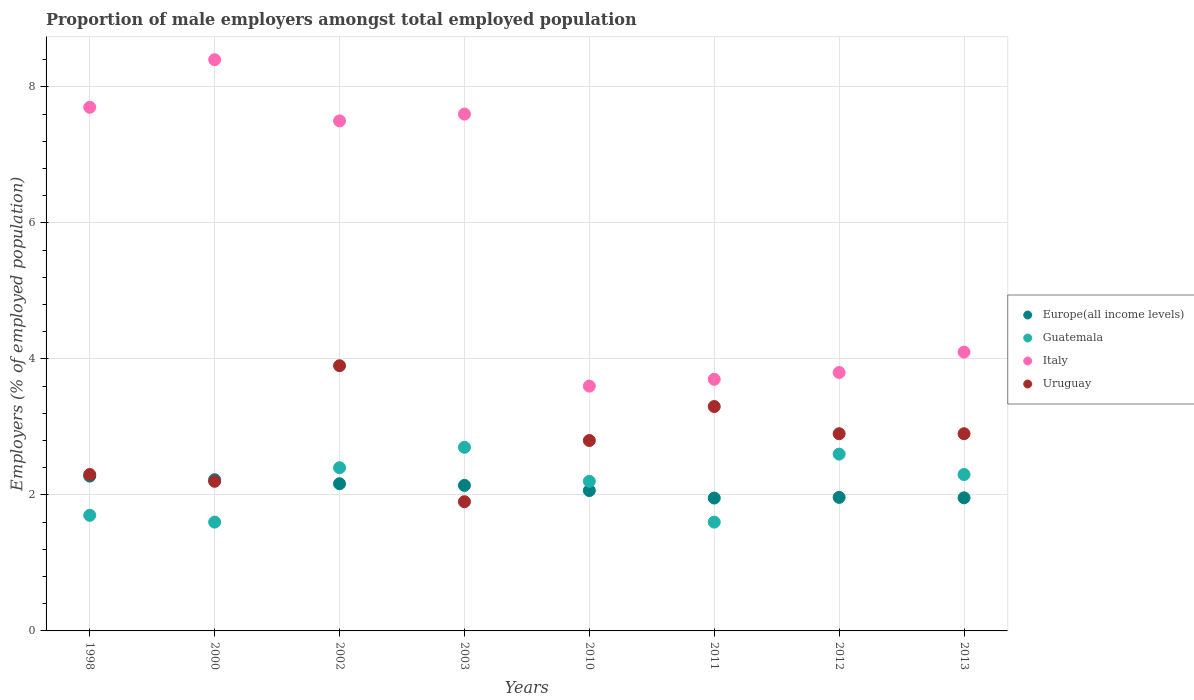How many different coloured dotlines are there?
Offer a terse response. 4. What is the proportion of male employers in Italy in 2010?
Ensure brevity in your answer.  3.6. Across all years, what is the maximum proportion of male employers in Uruguay?
Your answer should be very brief. 3.9. Across all years, what is the minimum proportion of male employers in Uruguay?
Your response must be concise. 1.9. What is the total proportion of male employers in Uruguay in the graph?
Give a very brief answer. 22.2. What is the difference between the proportion of male employers in Europe(all income levels) in 2002 and that in 2011?
Make the answer very short. 0.21. What is the difference between the proportion of male employers in Italy in 1998 and the proportion of male employers in Europe(all income levels) in 2012?
Offer a very short reply. 5.74. What is the average proportion of male employers in Italy per year?
Provide a short and direct response. 5.8. In the year 2012, what is the difference between the proportion of male employers in Italy and proportion of male employers in Uruguay?
Keep it short and to the point. 0.9. What is the ratio of the proportion of male employers in Uruguay in 2011 to that in 2013?
Offer a terse response. 1.14. Is the proportion of male employers in Uruguay in 2000 less than that in 2012?
Provide a succinct answer. Yes. What is the difference between the highest and the second highest proportion of male employers in Europe(all income levels)?
Make the answer very short. 0.05. What is the difference between the highest and the lowest proportion of male employers in Italy?
Your response must be concise. 4.8. In how many years, is the proportion of male employers in Europe(all income levels) greater than the average proportion of male employers in Europe(all income levels) taken over all years?
Your answer should be compact. 4. Is it the case that in every year, the sum of the proportion of male employers in Guatemala and proportion of male employers in Uruguay  is greater than the proportion of male employers in Italy?
Provide a short and direct response. No. How many dotlines are there?
Offer a very short reply. 4. What is the difference between two consecutive major ticks on the Y-axis?
Your answer should be compact. 2. How are the legend labels stacked?
Your response must be concise. Vertical. What is the title of the graph?
Offer a very short reply. Proportion of male employers amongst total employed population. What is the label or title of the X-axis?
Keep it short and to the point. Years. What is the label or title of the Y-axis?
Keep it short and to the point. Employers (% of employed population). What is the Employers (% of employed population) in Europe(all income levels) in 1998?
Provide a short and direct response. 2.28. What is the Employers (% of employed population) of Guatemala in 1998?
Provide a succinct answer. 1.7. What is the Employers (% of employed population) in Italy in 1998?
Give a very brief answer. 7.7. What is the Employers (% of employed population) in Uruguay in 1998?
Give a very brief answer. 2.3. What is the Employers (% of employed population) of Europe(all income levels) in 2000?
Offer a terse response. 2.22. What is the Employers (% of employed population) of Guatemala in 2000?
Your response must be concise. 1.6. What is the Employers (% of employed population) in Italy in 2000?
Your answer should be very brief. 8.4. What is the Employers (% of employed population) in Uruguay in 2000?
Provide a succinct answer. 2.2. What is the Employers (% of employed population) of Europe(all income levels) in 2002?
Your response must be concise. 2.16. What is the Employers (% of employed population) of Guatemala in 2002?
Provide a succinct answer. 2.4. What is the Employers (% of employed population) in Italy in 2002?
Your response must be concise. 7.5. What is the Employers (% of employed population) in Uruguay in 2002?
Ensure brevity in your answer.  3.9. What is the Employers (% of employed population) of Europe(all income levels) in 2003?
Keep it short and to the point. 2.14. What is the Employers (% of employed population) of Guatemala in 2003?
Give a very brief answer. 2.7. What is the Employers (% of employed population) in Italy in 2003?
Ensure brevity in your answer.  7.6. What is the Employers (% of employed population) in Uruguay in 2003?
Keep it short and to the point. 1.9. What is the Employers (% of employed population) of Europe(all income levels) in 2010?
Ensure brevity in your answer.  2.06. What is the Employers (% of employed population) in Guatemala in 2010?
Your answer should be compact. 2.2. What is the Employers (% of employed population) of Italy in 2010?
Your response must be concise. 3.6. What is the Employers (% of employed population) of Uruguay in 2010?
Your answer should be compact. 2.8. What is the Employers (% of employed population) of Europe(all income levels) in 2011?
Provide a succinct answer. 1.95. What is the Employers (% of employed population) in Guatemala in 2011?
Offer a very short reply. 1.6. What is the Employers (% of employed population) in Italy in 2011?
Provide a succinct answer. 3.7. What is the Employers (% of employed population) of Uruguay in 2011?
Keep it short and to the point. 3.3. What is the Employers (% of employed population) in Europe(all income levels) in 2012?
Your answer should be compact. 1.96. What is the Employers (% of employed population) of Guatemala in 2012?
Give a very brief answer. 2.6. What is the Employers (% of employed population) in Italy in 2012?
Offer a very short reply. 3.8. What is the Employers (% of employed population) of Uruguay in 2012?
Your answer should be very brief. 2.9. What is the Employers (% of employed population) in Europe(all income levels) in 2013?
Offer a very short reply. 1.96. What is the Employers (% of employed population) of Guatemala in 2013?
Your answer should be very brief. 2.3. What is the Employers (% of employed population) of Italy in 2013?
Keep it short and to the point. 4.1. What is the Employers (% of employed population) in Uruguay in 2013?
Provide a succinct answer. 2.9. Across all years, what is the maximum Employers (% of employed population) in Europe(all income levels)?
Make the answer very short. 2.28. Across all years, what is the maximum Employers (% of employed population) in Guatemala?
Your response must be concise. 2.7. Across all years, what is the maximum Employers (% of employed population) of Italy?
Your response must be concise. 8.4. Across all years, what is the maximum Employers (% of employed population) in Uruguay?
Your response must be concise. 3.9. Across all years, what is the minimum Employers (% of employed population) of Europe(all income levels)?
Offer a terse response. 1.95. Across all years, what is the minimum Employers (% of employed population) in Guatemala?
Your answer should be very brief. 1.6. Across all years, what is the minimum Employers (% of employed population) in Italy?
Provide a succinct answer. 3.6. Across all years, what is the minimum Employers (% of employed population) in Uruguay?
Provide a short and direct response. 1.9. What is the total Employers (% of employed population) in Europe(all income levels) in the graph?
Your answer should be compact. 16.74. What is the total Employers (% of employed population) in Italy in the graph?
Provide a short and direct response. 46.4. What is the difference between the Employers (% of employed population) of Europe(all income levels) in 1998 and that in 2000?
Your answer should be compact. 0.05. What is the difference between the Employers (% of employed population) of Europe(all income levels) in 1998 and that in 2002?
Your answer should be compact. 0.11. What is the difference between the Employers (% of employed population) of Guatemala in 1998 and that in 2002?
Offer a terse response. -0.7. What is the difference between the Employers (% of employed population) of Italy in 1998 and that in 2002?
Keep it short and to the point. 0.2. What is the difference between the Employers (% of employed population) in Uruguay in 1998 and that in 2002?
Ensure brevity in your answer.  -1.6. What is the difference between the Employers (% of employed population) in Europe(all income levels) in 1998 and that in 2003?
Keep it short and to the point. 0.14. What is the difference between the Employers (% of employed population) of Uruguay in 1998 and that in 2003?
Provide a succinct answer. 0.4. What is the difference between the Employers (% of employed population) of Europe(all income levels) in 1998 and that in 2010?
Offer a very short reply. 0.21. What is the difference between the Employers (% of employed population) in Europe(all income levels) in 1998 and that in 2011?
Keep it short and to the point. 0.32. What is the difference between the Employers (% of employed population) of Italy in 1998 and that in 2011?
Keep it short and to the point. 4. What is the difference between the Employers (% of employed population) of Europe(all income levels) in 1998 and that in 2012?
Make the answer very short. 0.31. What is the difference between the Employers (% of employed population) in Guatemala in 1998 and that in 2012?
Keep it short and to the point. -0.9. What is the difference between the Employers (% of employed population) in Italy in 1998 and that in 2012?
Offer a terse response. 3.9. What is the difference between the Employers (% of employed population) in Europe(all income levels) in 1998 and that in 2013?
Provide a short and direct response. 0.32. What is the difference between the Employers (% of employed population) of Uruguay in 1998 and that in 2013?
Make the answer very short. -0.6. What is the difference between the Employers (% of employed population) of Europe(all income levels) in 2000 and that in 2002?
Provide a succinct answer. 0.06. What is the difference between the Employers (% of employed population) in Italy in 2000 and that in 2002?
Your answer should be very brief. 0.9. What is the difference between the Employers (% of employed population) of Uruguay in 2000 and that in 2002?
Your answer should be very brief. -1.7. What is the difference between the Employers (% of employed population) of Europe(all income levels) in 2000 and that in 2003?
Your response must be concise. 0.08. What is the difference between the Employers (% of employed population) of Uruguay in 2000 and that in 2003?
Offer a terse response. 0.3. What is the difference between the Employers (% of employed population) in Europe(all income levels) in 2000 and that in 2010?
Give a very brief answer. 0.16. What is the difference between the Employers (% of employed population) of Italy in 2000 and that in 2010?
Offer a terse response. 4.8. What is the difference between the Employers (% of employed population) in Europe(all income levels) in 2000 and that in 2011?
Provide a short and direct response. 0.27. What is the difference between the Employers (% of employed population) of Italy in 2000 and that in 2011?
Your response must be concise. 4.7. What is the difference between the Employers (% of employed population) in Europe(all income levels) in 2000 and that in 2012?
Make the answer very short. 0.26. What is the difference between the Employers (% of employed population) in Guatemala in 2000 and that in 2012?
Make the answer very short. -1. What is the difference between the Employers (% of employed population) in Italy in 2000 and that in 2012?
Offer a terse response. 4.6. What is the difference between the Employers (% of employed population) in Europe(all income levels) in 2000 and that in 2013?
Your answer should be compact. 0.27. What is the difference between the Employers (% of employed population) in Guatemala in 2000 and that in 2013?
Your response must be concise. -0.7. What is the difference between the Employers (% of employed population) of Europe(all income levels) in 2002 and that in 2003?
Provide a succinct answer. 0.02. What is the difference between the Employers (% of employed population) of Guatemala in 2002 and that in 2003?
Keep it short and to the point. -0.3. What is the difference between the Employers (% of employed population) of Europe(all income levels) in 2002 and that in 2010?
Give a very brief answer. 0.1. What is the difference between the Employers (% of employed population) of Guatemala in 2002 and that in 2010?
Your answer should be compact. 0.2. What is the difference between the Employers (% of employed population) in Italy in 2002 and that in 2010?
Your answer should be very brief. 3.9. What is the difference between the Employers (% of employed population) of Uruguay in 2002 and that in 2010?
Keep it short and to the point. 1.1. What is the difference between the Employers (% of employed population) in Europe(all income levels) in 2002 and that in 2011?
Your response must be concise. 0.21. What is the difference between the Employers (% of employed population) in Guatemala in 2002 and that in 2011?
Keep it short and to the point. 0.8. What is the difference between the Employers (% of employed population) in Italy in 2002 and that in 2011?
Offer a very short reply. 3.8. What is the difference between the Employers (% of employed population) of Europe(all income levels) in 2002 and that in 2012?
Give a very brief answer. 0.2. What is the difference between the Employers (% of employed population) of Italy in 2002 and that in 2012?
Provide a succinct answer. 3.7. What is the difference between the Employers (% of employed population) of Europe(all income levels) in 2002 and that in 2013?
Offer a terse response. 0.21. What is the difference between the Employers (% of employed population) in Guatemala in 2002 and that in 2013?
Provide a succinct answer. 0.1. What is the difference between the Employers (% of employed population) in Italy in 2002 and that in 2013?
Your response must be concise. 3.4. What is the difference between the Employers (% of employed population) in Europe(all income levels) in 2003 and that in 2010?
Offer a very short reply. 0.08. What is the difference between the Employers (% of employed population) in Guatemala in 2003 and that in 2010?
Ensure brevity in your answer.  0.5. What is the difference between the Employers (% of employed population) of Europe(all income levels) in 2003 and that in 2011?
Your answer should be very brief. 0.19. What is the difference between the Employers (% of employed population) in Guatemala in 2003 and that in 2011?
Offer a terse response. 1.1. What is the difference between the Employers (% of employed population) of Italy in 2003 and that in 2011?
Make the answer very short. 3.9. What is the difference between the Employers (% of employed population) in Europe(all income levels) in 2003 and that in 2012?
Provide a short and direct response. 0.18. What is the difference between the Employers (% of employed population) in Europe(all income levels) in 2003 and that in 2013?
Offer a terse response. 0.18. What is the difference between the Employers (% of employed population) in Guatemala in 2003 and that in 2013?
Provide a short and direct response. 0.4. What is the difference between the Employers (% of employed population) of Italy in 2003 and that in 2013?
Keep it short and to the point. 3.5. What is the difference between the Employers (% of employed population) of Europe(all income levels) in 2010 and that in 2011?
Offer a terse response. 0.11. What is the difference between the Employers (% of employed population) in Guatemala in 2010 and that in 2011?
Offer a terse response. 0.6. What is the difference between the Employers (% of employed population) of Uruguay in 2010 and that in 2011?
Make the answer very short. -0.5. What is the difference between the Employers (% of employed population) of Europe(all income levels) in 2010 and that in 2012?
Make the answer very short. 0.1. What is the difference between the Employers (% of employed population) of Italy in 2010 and that in 2012?
Ensure brevity in your answer.  -0.2. What is the difference between the Employers (% of employed population) in Europe(all income levels) in 2010 and that in 2013?
Provide a short and direct response. 0.11. What is the difference between the Employers (% of employed population) in Uruguay in 2010 and that in 2013?
Your answer should be compact. -0.1. What is the difference between the Employers (% of employed population) in Europe(all income levels) in 2011 and that in 2012?
Your answer should be very brief. -0.01. What is the difference between the Employers (% of employed population) in Guatemala in 2011 and that in 2012?
Your answer should be very brief. -1. What is the difference between the Employers (% of employed population) in Italy in 2011 and that in 2012?
Provide a succinct answer. -0.1. What is the difference between the Employers (% of employed population) in Uruguay in 2011 and that in 2012?
Your answer should be very brief. 0.4. What is the difference between the Employers (% of employed population) in Europe(all income levels) in 2011 and that in 2013?
Make the answer very short. -0. What is the difference between the Employers (% of employed population) of Europe(all income levels) in 2012 and that in 2013?
Your response must be concise. 0.01. What is the difference between the Employers (% of employed population) of Guatemala in 2012 and that in 2013?
Ensure brevity in your answer.  0.3. What is the difference between the Employers (% of employed population) in Uruguay in 2012 and that in 2013?
Provide a succinct answer. 0. What is the difference between the Employers (% of employed population) in Europe(all income levels) in 1998 and the Employers (% of employed population) in Guatemala in 2000?
Your answer should be very brief. 0.68. What is the difference between the Employers (% of employed population) in Europe(all income levels) in 1998 and the Employers (% of employed population) in Italy in 2000?
Keep it short and to the point. -6.12. What is the difference between the Employers (% of employed population) of Europe(all income levels) in 1998 and the Employers (% of employed population) of Uruguay in 2000?
Your response must be concise. 0.08. What is the difference between the Employers (% of employed population) in Guatemala in 1998 and the Employers (% of employed population) in Uruguay in 2000?
Give a very brief answer. -0.5. What is the difference between the Employers (% of employed population) of Europe(all income levels) in 1998 and the Employers (% of employed population) of Guatemala in 2002?
Your answer should be very brief. -0.12. What is the difference between the Employers (% of employed population) in Europe(all income levels) in 1998 and the Employers (% of employed population) in Italy in 2002?
Give a very brief answer. -5.22. What is the difference between the Employers (% of employed population) of Europe(all income levels) in 1998 and the Employers (% of employed population) of Uruguay in 2002?
Your answer should be compact. -1.62. What is the difference between the Employers (% of employed population) in Italy in 1998 and the Employers (% of employed population) in Uruguay in 2002?
Provide a succinct answer. 3.8. What is the difference between the Employers (% of employed population) of Europe(all income levels) in 1998 and the Employers (% of employed population) of Guatemala in 2003?
Give a very brief answer. -0.42. What is the difference between the Employers (% of employed population) in Europe(all income levels) in 1998 and the Employers (% of employed population) in Italy in 2003?
Make the answer very short. -5.32. What is the difference between the Employers (% of employed population) of Europe(all income levels) in 1998 and the Employers (% of employed population) of Uruguay in 2003?
Offer a terse response. 0.38. What is the difference between the Employers (% of employed population) of Guatemala in 1998 and the Employers (% of employed population) of Italy in 2003?
Your response must be concise. -5.9. What is the difference between the Employers (% of employed population) in Guatemala in 1998 and the Employers (% of employed population) in Uruguay in 2003?
Your answer should be very brief. -0.2. What is the difference between the Employers (% of employed population) in Italy in 1998 and the Employers (% of employed population) in Uruguay in 2003?
Make the answer very short. 5.8. What is the difference between the Employers (% of employed population) of Europe(all income levels) in 1998 and the Employers (% of employed population) of Guatemala in 2010?
Ensure brevity in your answer.  0.08. What is the difference between the Employers (% of employed population) of Europe(all income levels) in 1998 and the Employers (% of employed population) of Italy in 2010?
Provide a succinct answer. -1.32. What is the difference between the Employers (% of employed population) of Europe(all income levels) in 1998 and the Employers (% of employed population) of Uruguay in 2010?
Make the answer very short. -0.52. What is the difference between the Employers (% of employed population) of Guatemala in 1998 and the Employers (% of employed population) of Uruguay in 2010?
Your response must be concise. -1.1. What is the difference between the Employers (% of employed population) of Europe(all income levels) in 1998 and the Employers (% of employed population) of Guatemala in 2011?
Provide a short and direct response. 0.68. What is the difference between the Employers (% of employed population) in Europe(all income levels) in 1998 and the Employers (% of employed population) in Italy in 2011?
Ensure brevity in your answer.  -1.42. What is the difference between the Employers (% of employed population) of Europe(all income levels) in 1998 and the Employers (% of employed population) of Uruguay in 2011?
Your answer should be very brief. -1.02. What is the difference between the Employers (% of employed population) in Guatemala in 1998 and the Employers (% of employed population) in Uruguay in 2011?
Your answer should be very brief. -1.6. What is the difference between the Employers (% of employed population) of Italy in 1998 and the Employers (% of employed population) of Uruguay in 2011?
Ensure brevity in your answer.  4.4. What is the difference between the Employers (% of employed population) of Europe(all income levels) in 1998 and the Employers (% of employed population) of Guatemala in 2012?
Provide a succinct answer. -0.32. What is the difference between the Employers (% of employed population) of Europe(all income levels) in 1998 and the Employers (% of employed population) of Italy in 2012?
Your response must be concise. -1.52. What is the difference between the Employers (% of employed population) in Europe(all income levels) in 1998 and the Employers (% of employed population) in Uruguay in 2012?
Ensure brevity in your answer.  -0.62. What is the difference between the Employers (% of employed population) of Guatemala in 1998 and the Employers (% of employed population) of Uruguay in 2012?
Offer a terse response. -1.2. What is the difference between the Employers (% of employed population) in Italy in 1998 and the Employers (% of employed population) in Uruguay in 2012?
Give a very brief answer. 4.8. What is the difference between the Employers (% of employed population) of Europe(all income levels) in 1998 and the Employers (% of employed population) of Guatemala in 2013?
Provide a short and direct response. -0.02. What is the difference between the Employers (% of employed population) of Europe(all income levels) in 1998 and the Employers (% of employed population) of Italy in 2013?
Provide a short and direct response. -1.82. What is the difference between the Employers (% of employed population) of Europe(all income levels) in 1998 and the Employers (% of employed population) of Uruguay in 2013?
Your answer should be compact. -0.62. What is the difference between the Employers (% of employed population) of Italy in 1998 and the Employers (% of employed population) of Uruguay in 2013?
Make the answer very short. 4.8. What is the difference between the Employers (% of employed population) of Europe(all income levels) in 2000 and the Employers (% of employed population) of Guatemala in 2002?
Give a very brief answer. -0.18. What is the difference between the Employers (% of employed population) in Europe(all income levels) in 2000 and the Employers (% of employed population) in Italy in 2002?
Your answer should be very brief. -5.28. What is the difference between the Employers (% of employed population) of Europe(all income levels) in 2000 and the Employers (% of employed population) of Uruguay in 2002?
Keep it short and to the point. -1.68. What is the difference between the Employers (% of employed population) of Guatemala in 2000 and the Employers (% of employed population) of Italy in 2002?
Your answer should be very brief. -5.9. What is the difference between the Employers (% of employed population) in Europe(all income levels) in 2000 and the Employers (% of employed population) in Guatemala in 2003?
Provide a succinct answer. -0.48. What is the difference between the Employers (% of employed population) of Europe(all income levels) in 2000 and the Employers (% of employed population) of Italy in 2003?
Keep it short and to the point. -5.38. What is the difference between the Employers (% of employed population) in Europe(all income levels) in 2000 and the Employers (% of employed population) in Uruguay in 2003?
Ensure brevity in your answer.  0.32. What is the difference between the Employers (% of employed population) of Guatemala in 2000 and the Employers (% of employed population) of Italy in 2003?
Your answer should be compact. -6. What is the difference between the Employers (% of employed population) in Italy in 2000 and the Employers (% of employed population) in Uruguay in 2003?
Keep it short and to the point. 6.5. What is the difference between the Employers (% of employed population) of Europe(all income levels) in 2000 and the Employers (% of employed population) of Guatemala in 2010?
Your answer should be very brief. 0.02. What is the difference between the Employers (% of employed population) in Europe(all income levels) in 2000 and the Employers (% of employed population) in Italy in 2010?
Offer a very short reply. -1.38. What is the difference between the Employers (% of employed population) in Europe(all income levels) in 2000 and the Employers (% of employed population) in Uruguay in 2010?
Your answer should be very brief. -0.58. What is the difference between the Employers (% of employed population) of Guatemala in 2000 and the Employers (% of employed population) of Uruguay in 2010?
Your answer should be very brief. -1.2. What is the difference between the Employers (% of employed population) in Europe(all income levels) in 2000 and the Employers (% of employed population) in Guatemala in 2011?
Offer a very short reply. 0.62. What is the difference between the Employers (% of employed population) of Europe(all income levels) in 2000 and the Employers (% of employed population) of Italy in 2011?
Your answer should be compact. -1.48. What is the difference between the Employers (% of employed population) in Europe(all income levels) in 2000 and the Employers (% of employed population) in Uruguay in 2011?
Give a very brief answer. -1.08. What is the difference between the Employers (% of employed population) in Europe(all income levels) in 2000 and the Employers (% of employed population) in Guatemala in 2012?
Ensure brevity in your answer.  -0.38. What is the difference between the Employers (% of employed population) in Europe(all income levels) in 2000 and the Employers (% of employed population) in Italy in 2012?
Provide a succinct answer. -1.58. What is the difference between the Employers (% of employed population) of Europe(all income levels) in 2000 and the Employers (% of employed population) of Uruguay in 2012?
Your answer should be compact. -0.68. What is the difference between the Employers (% of employed population) in Guatemala in 2000 and the Employers (% of employed population) in Italy in 2012?
Give a very brief answer. -2.2. What is the difference between the Employers (% of employed population) in Europe(all income levels) in 2000 and the Employers (% of employed population) in Guatemala in 2013?
Offer a terse response. -0.08. What is the difference between the Employers (% of employed population) in Europe(all income levels) in 2000 and the Employers (% of employed population) in Italy in 2013?
Your response must be concise. -1.88. What is the difference between the Employers (% of employed population) in Europe(all income levels) in 2000 and the Employers (% of employed population) in Uruguay in 2013?
Keep it short and to the point. -0.68. What is the difference between the Employers (% of employed population) in Guatemala in 2000 and the Employers (% of employed population) in Italy in 2013?
Make the answer very short. -2.5. What is the difference between the Employers (% of employed population) of Italy in 2000 and the Employers (% of employed population) of Uruguay in 2013?
Offer a terse response. 5.5. What is the difference between the Employers (% of employed population) in Europe(all income levels) in 2002 and the Employers (% of employed population) in Guatemala in 2003?
Provide a succinct answer. -0.54. What is the difference between the Employers (% of employed population) of Europe(all income levels) in 2002 and the Employers (% of employed population) of Italy in 2003?
Provide a succinct answer. -5.44. What is the difference between the Employers (% of employed population) of Europe(all income levels) in 2002 and the Employers (% of employed population) of Uruguay in 2003?
Provide a succinct answer. 0.26. What is the difference between the Employers (% of employed population) of Guatemala in 2002 and the Employers (% of employed population) of Italy in 2003?
Make the answer very short. -5.2. What is the difference between the Employers (% of employed population) in Guatemala in 2002 and the Employers (% of employed population) in Uruguay in 2003?
Your answer should be compact. 0.5. What is the difference between the Employers (% of employed population) of Europe(all income levels) in 2002 and the Employers (% of employed population) of Guatemala in 2010?
Provide a succinct answer. -0.04. What is the difference between the Employers (% of employed population) in Europe(all income levels) in 2002 and the Employers (% of employed population) in Italy in 2010?
Your response must be concise. -1.44. What is the difference between the Employers (% of employed population) of Europe(all income levels) in 2002 and the Employers (% of employed population) of Uruguay in 2010?
Ensure brevity in your answer.  -0.64. What is the difference between the Employers (% of employed population) in Guatemala in 2002 and the Employers (% of employed population) in Italy in 2010?
Offer a very short reply. -1.2. What is the difference between the Employers (% of employed population) of Guatemala in 2002 and the Employers (% of employed population) of Uruguay in 2010?
Your answer should be compact. -0.4. What is the difference between the Employers (% of employed population) in Europe(all income levels) in 2002 and the Employers (% of employed population) in Guatemala in 2011?
Your response must be concise. 0.56. What is the difference between the Employers (% of employed population) in Europe(all income levels) in 2002 and the Employers (% of employed population) in Italy in 2011?
Your answer should be very brief. -1.54. What is the difference between the Employers (% of employed population) of Europe(all income levels) in 2002 and the Employers (% of employed population) of Uruguay in 2011?
Ensure brevity in your answer.  -1.14. What is the difference between the Employers (% of employed population) of Guatemala in 2002 and the Employers (% of employed population) of Italy in 2011?
Provide a succinct answer. -1.3. What is the difference between the Employers (% of employed population) in Europe(all income levels) in 2002 and the Employers (% of employed population) in Guatemala in 2012?
Your answer should be compact. -0.44. What is the difference between the Employers (% of employed population) of Europe(all income levels) in 2002 and the Employers (% of employed population) of Italy in 2012?
Give a very brief answer. -1.64. What is the difference between the Employers (% of employed population) of Europe(all income levels) in 2002 and the Employers (% of employed population) of Uruguay in 2012?
Your response must be concise. -0.74. What is the difference between the Employers (% of employed population) in Guatemala in 2002 and the Employers (% of employed population) in Uruguay in 2012?
Ensure brevity in your answer.  -0.5. What is the difference between the Employers (% of employed population) in Europe(all income levels) in 2002 and the Employers (% of employed population) in Guatemala in 2013?
Your answer should be very brief. -0.14. What is the difference between the Employers (% of employed population) in Europe(all income levels) in 2002 and the Employers (% of employed population) in Italy in 2013?
Your response must be concise. -1.94. What is the difference between the Employers (% of employed population) in Europe(all income levels) in 2002 and the Employers (% of employed population) in Uruguay in 2013?
Provide a short and direct response. -0.74. What is the difference between the Employers (% of employed population) in Guatemala in 2002 and the Employers (% of employed population) in Italy in 2013?
Your answer should be very brief. -1.7. What is the difference between the Employers (% of employed population) of Europe(all income levels) in 2003 and the Employers (% of employed population) of Guatemala in 2010?
Your response must be concise. -0.06. What is the difference between the Employers (% of employed population) of Europe(all income levels) in 2003 and the Employers (% of employed population) of Italy in 2010?
Make the answer very short. -1.46. What is the difference between the Employers (% of employed population) of Europe(all income levels) in 2003 and the Employers (% of employed population) of Uruguay in 2010?
Make the answer very short. -0.66. What is the difference between the Employers (% of employed population) in Guatemala in 2003 and the Employers (% of employed population) in Italy in 2010?
Your answer should be compact. -0.9. What is the difference between the Employers (% of employed population) of Europe(all income levels) in 2003 and the Employers (% of employed population) of Guatemala in 2011?
Your response must be concise. 0.54. What is the difference between the Employers (% of employed population) in Europe(all income levels) in 2003 and the Employers (% of employed population) in Italy in 2011?
Ensure brevity in your answer.  -1.56. What is the difference between the Employers (% of employed population) of Europe(all income levels) in 2003 and the Employers (% of employed population) of Uruguay in 2011?
Keep it short and to the point. -1.16. What is the difference between the Employers (% of employed population) in Guatemala in 2003 and the Employers (% of employed population) in Uruguay in 2011?
Offer a terse response. -0.6. What is the difference between the Employers (% of employed population) in Europe(all income levels) in 2003 and the Employers (% of employed population) in Guatemala in 2012?
Make the answer very short. -0.46. What is the difference between the Employers (% of employed population) of Europe(all income levels) in 2003 and the Employers (% of employed population) of Italy in 2012?
Make the answer very short. -1.66. What is the difference between the Employers (% of employed population) of Europe(all income levels) in 2003 and the Employers (% of employed population) of Uruguay in 2012?
Your response must be concise. -0.76. What is the difference between the Employers (% of employed population) of Guatemala in 2003 and the Employers (% of employed population) of Uruguay in 2012?
Provide a short and direct response. -0.2. What is the difference between the Employers (% of employed population) of Europe(all income levels) in 2003 and the Employers (% of employed population) of Guatemala in 2013?
Give a very brief answer. -0.16. What is the difference between the Employers (% of employed population) of Europe(all income levels) in 2003 and the Employers (% of employed population) of Italy in 2013?
Ensure brevity in your answer.  -1.96. What is the difference between the Employers (% of employed population) of Europe(all income levels) in 2003 and the Employers (% of employed population) of Uruguay in 2013?
Offer a very short reply. -0.76. What is the difference between the Employers (% of employed population) in Guatemala in 2003 and the Employers (% of employed population) in Uruguay in 2013?
Provide a succinct answer. -0.2. What is the difference between the Employers (% of employed population) of Europe(all income levels) in 2010 and the Employers (% of employed population) of Guatemala in 2011?
Make the answer very short. 0.46. What is the difference between the Employers (% of employed population) of Europe(all income levels) in 2010 and the Employers (% of employed population) of Italy in 2011?
Provide a succinct answer. -1.64. What is the difference between the Employers (% of employed population) in Europe(all income levels) in 2010 and the Employers (% of employed population) in Uruguay in 2011?
Give a very brief answer. -1.24. What is the difference between the Employers (% of employed population) in Guatemala in 2010 and the Employers (% of employed population) in Italy in 2011?
Make the answer very short. -1.5. What is the difference between the Employers (% of employed population) of Italy in 2010 and the Employers (% of employed population) of Uruguay in 2011?
Offer a terse response. 0.3. What is the difference between the Employers (% of employed population) of Europe(all income levels) in 2010 and the Employers (% of employed population) of Guatemala in 2012?
Keep it short and to the point. -0.54. What is the difference between the Employers (% of employed population) of Europe(all income levels) in 2010 and the Employers (% of employed population) of Italy in 2012?
Keep it short and to the point. -1.74. What is the difference between the Employers (% of employed population) in Europe(all income levels) in 2010 and the Employers (% of employed population) in Uruguay in 2012?
Your answer should be compact. -0.84. What is the difference between the Employers (% of employed population) in Guatemala in 2010 and the Employers (% of employed population) in Italy in 2012?
Make the answer very short. -1.6. What is the difference between the Employers (% of employed population) in Europe(all income levels) in 2010 and the Employers (% of employed population) in Guatemala in 2013?
Offer a terse response. -0.24. What is the difference between the Employers (% of employed population) of Europe(all income levels) in 2010 and the Employers (% of employed population) of Italy in 2013?
Your response must be concise. -2.04. What is the difference between the Employers (% of employed population) of Europe(all income levels) in 2010 and the Employers (% of employed population) of Uruguay in 2013?
Make the answer very short. -0.84. What is the difference between the Employers (% of employed population) in Italy in 2010 and the Employers (% of employed population) in Uruguay in 2013?
Your response must be concise. 0.7. What is the difference between the Employers (% of employed population) in Europe(all income levels) in 2011 and the Employers (% of employed population) in Guatemala in 2012?
Your answer should be very brief. -0.65. What is the difference between the Employers (% of employed population) in Europe(all income levels) in 2011 and the Employers (% of employed population) in Italy in 2012?
Provide a short and direct response. -1.85. What is the difference between the Employers (% of employed population) of Europe(all income levels) in 2011 and the Employers (% of employed population) of Uruguay in 2012?
Make the answer very short. -0.95. What is the difference between the Employers (% of employed population) in Guatemala in 2011 and the Employers (% of employed population) in Uruguay in 2012?
Provide a short and direct response. -1.3. What is the difference between the Employers (% of employed population) of Europe(all income levels) in 2011 and the Employers (% of employed population) of Guatemala in 2013?
Your answer should be very brief. -0.35. What is the difference between the Employers (% of employed population) in Europe(all income levels) in 2011 and the Employers (% of employed population) in Italy in 2013?
Offer a terse response. -2.15. What is the difference between the Employers (% of employed population) of Europe(all income levels) in 2011 and the Employers (% of employed population) of Uruguay in 2013?
Your response must be concise. -0.95. What is the difference between the Employers (% of employed population) in Guatemala in 2011 and the Employers (% of employed population) in Italy in 2013?
Keep it short and to the point. -2.5. What is the difference between the Employers (% of employed population) in Europe(all income levels) in 2012 and the Employers (% of employed population) in Guatemala in 2013?
Provide a succinct answer. -0.34. What is the difference between the Employers (% of employed population) in Europe(all income levels) in 2012 and the Employers (% of employed population) in Italy in 2013?
Provide a succinct answer. -2.14. What is the difference between the Employers (% of employed population) of Europe(all income levels) in 2012 and the Employers (% of employed population) of Uruguay in 2013?
Your answer should be very brief. -0.94. What is the difference between the Employers (% of employed population) of Italy in 2012 and the Employers (% of employed population) of Uruguay in 2013?
Offer a very short reply. 0.9. What is the average Employers (% of employed population) in Europe(all income levels) per year?
Ensure brevity in your answer.  2.09. What is the average Employers (% of employed population) of Guatemala per year?
Ensure brevity in your answer.  2.14. What is the average Employers (% of employed population) of Uruguay per year?
Keep it short and to the point. 2.77. In the year 1998, what is the difference between the Employers (% of employed population) of Europe(all income levels) and Employers (% of employed population) of Guatemala?
Give a very brief answer. 0.58. In the year 1998, what is the difference between the Employers (% of employed population) in Europe(all income levels) and Employers (% of employed population) in Italy?
Keep it short and to the point. -5.42. In the year 1998, what is the difference between the Employers (% of employed population) of Europe(all income levels) and Employers (% of employed population) of Uruguay?
Offer a terse response. -0.02. In the year 1998, what is the difference between the Employers (% of employed population) in Italy and Employers (% of employed population) in Uruguay?
Offer a terse response. 5.4. In the year 2000, what is the difference between the Employers (% of employed population) of Europe(all income levels) and Employers (% of employed population) of Guatemala?
Your response must be concise. 0.62. In the year 2000, what is the difference between the Employers (% of employed population) of Europe(all income levels) and Employers (% of employed population) of Italy?
Keep it short and to the point. -6.18. In the year 2000, what is the difference between the Employers (% of employed population) of Europe(all income levels) and Employers (% of employed population) of Uruguay?
Offer a very short reply. 0.02. In the year 2000, what is the difference between the Employers (% of employed population) of Guatemala and Employers (% of employed population) of Uruguay?
Give a very brief answer. -0.6. In the year 2002, what is the difference between the Employers (% of employed population) in Europe(all income levels) and Employers (% of employed population) in Guatemala?
Provide a succinct answer. -0.24. In the year 2002, what is the difference between the Employers (% of employed population) in Europe(all income levels) and Employers (% of employed population) in Italy?
Provide a succinct answer. -5.34. In the year 2002, what is the difference between the Employers (% of employed population) in Europe(all income levels) and Employers (% of employed population) in Uruguay?
Your answer should be compact. -1.74. In the year 2002, what is the difference between the Employers (% of employed population) of Italy and Employers (% of employed population) of Uruguay?
Offer a terse response. 3.6. In the year 2003, what is the difference between the Employers (% of employed population) in Europe(all income levels) and Employers (% of employed population) in Guatemala?
Your response must be concise. -0.56. In the year 2003, what is the difference between the Employers (% of employed population) in Europe(all income levels) and Employers (% of employed population) in Italy?
Your answer should be compact. -5.46. In the year 2003, what is the difference between the Employers (% of employed population) in Europe(all income levels) and Employers (% of employed population) in Uruguay?
Keep it short and to the point. 0.24. In the year 2010, what is the difference between the Employers (% of employed population) of Europe(all income levels) and Employers (% of employed population) of Guatemala?
Provide a succinct answer. -0.14. In the year 2010, what is the difference between the Employers (% of employed population) of Europe(all income levels) and Employers (% of employed population) of Italy?
Offer a very short reply. -1.54. In the year 2010, what is the difference between the Employers (% of employed population) of Europe(all income levels) and Employers (% of employed population) of Uruguay?
Ensure brevity in your answer.  -0.74. In the year 2010, what is the difference between the Employers (% of employed population) of Guatemala and Employers (% of employed population) of Italy?
Keep it short and to the point. -1.4. In the year 2011, what is the difference between the Employers (% of employed population) in Europe(all income levels) and Employers (% of employed population) in Guatemala?
Keep it short and to the point. 0.35. In the year 2011, what is the difference between the Employers (% of employed population) of Europe(all income levels) and Employers (% of employed population) of Italy?
Make the answer very short. -1.75. In the year 2011, what is the difference between the Employers (% of employed population) in Europe(all income levels) and Employers (% of employed population) in Uruguay?
Your response must be concise. -1.35. In the year 2011, what is the difference between the Employers (% of employed population) of Guatemala and Employers (% of employed population) of Uruguay?
Give a very brief answer. -1.7. In the year 2011, what is the difference between the Employers (% of employed population) in Italy and Employers (% of employed population) in Uruguay?
Ensure brevity in your answer.  0.4. In the year 2012, what is the difference between the Employers (% of employed population) in Europe(all income levels) and Employers (% of employed population) in Guatemala?
Ensure brevity in your answer.  -0.64. In the year 2012, what is the difference between the Employers (% of employed population) of Europe(all income levels) and Employers (% of employed population) of Italy?
Offer a terse response. -1.84. In the year 2012, what is the difference between the Employers (% of employed population) in Europe(all income levels) and Employers (% of employed population) in Uruguay?
Your response must be concise. -0.94. In the year 2013, what is the difference between the Employers (% of employed population) in Europe(all income levels) and Employers (% of employed population) in Guatemala?
Your response must be concise. -0.34. In the year 2013, what is the difference between the Employers (% of employed population) of Europe(all income levels) and Employers (% of employed population) of Italy?
Provide a succinct answer. -2.14. In the year 2013, what is the difference between the Employers (% of employed population) in Europe(all income levels) and Employers (% of employed population) in Uruguay?
Keep it short and to the point. -0.94. In the year 2013, what is the difference between the Employers (% of employed population) of Guatemala and Employers (% of employed population) of Italy?
Provide a succinct answer. -1.8. In the year 2013, what is the difference between the Employers (% of employed population) in Guatemala and Employers (% of employed population) in Uruguay?
Provide a short and direct response. -0.6. In the year 2013, what is the difference between the Employers (% of employed population) in Italy and Employers (% of employed population) in Uruguay?
Keep it short and to the point. 1.2. What is the ratio of the Employers (% of employed population) in Europe(all income levels) in 1998 to that in 2000?
Your response must be concise. 1.02. What is the ratio of the Employers (% of employed population) of Guatemala in 1998 to that in 2000?
Offer a very short reply. 1.06. What is the ratio of the Employers (% of employed population) in Italy in 1998 to that in 2000?
Provide a short and direct response. 0.92. What is the ratio of the Employers (% of employed population) of Uruguay in 1998 to that in 2000?
Your answer should be very brief. 1.05. What is the ratio of the Employers (% of employed population) of Europe(all income levels) in 1998 to that in 2002?
Make the answer very short. 1.05. What is the ratio of the Employers (% of employed population) in Guatemala in 1998 to that in 2002?
Give a very brief answer. 0.71. What is the ratio of the Employers (% of employed population) in Italy in 1998 to that in 2002?
Provide a succinct answer. 1.03. What is the ratio of the Employers (% of employed population) in Uruguay in 1998 to that in 2002?
Your response must be concise. 0.59. What is the ratio of the Employers (% of employed population) in Europe(all income levels) in 1998 to that in 2003?
Offer a terse response. 1.06. What is the ratio of the Employers (% of employed population) of Guatemala in 1998 to that in 2003?
Provide a short and direct response. 0.63. What is the ratio of the Employers (% of employed population) in Italy in 1998 to that in 2003?
Ensure brevity in your answer.  1.01. What is the ratio of the Employers (% of employed population) in Uruguay in 1998 to that in 2003?
Give a very brief answer. 1.21. What is the ratio of the Employers (% of employed population) in Europe(all income levels) in 1998 to that in 2010?
Your answer should be compact. 1.1. What is the ratio of the Employers (% of employed population) in Guatemala in 1998 to that in 2010?
Offer a very short reply. 0.77. What is the ratio of the Employers (% of employed population) of Italy in 1998 to that in 2010?
Offer a terse response. 2.14. What is the ratio of the Employers (% of employed population) of Uruguay in 1998 to that in 2010?
Provide a succinct answer. 0.82. What is the ratio of the Employers (% of employed population) in Europe(all income levels) in 1998 to that in 2011?
Your response must be concise. 1.17. What is the ratio of the Employers (% of employed population) of Guatemala in 1998 to that in 2011?
Offer a very short reply. 1.06. What is the ratio of the Employers (% of employed population) in Italy in 1998 to that in 2011?
Provide a succinct answer. 2.08. What is the ratio of the Employers (% of employed population) of Uruguay in 1998 to that in 2011?
Your answer should be compact. 0.7. What is the ratio of the Employers (% of employed population) of Europe(all income levels) in 1998 to that in 2012?
Offer a terse response. 1.16. What is the ratio of the Employers (% of employed population) of Guatemala in 1998 to that in 2012?
Your response must be concise. 0.65. What is the ratio of the Employers (% of employed population) in Italy in 1998 to that in 2012?
Offer a terse response. 2.03. What is the ratio of the Employers (% of employed population) of Uruguay in 1998 to that in 2012?
Keep it short and to the point. 0.79. What is the ratio of the Employers (% of employed population) in Europe(all income levels) in 1998 to that in 2013?
Keep it short and to the point. 1.16. What is the ratio of the Employers (% of employed population) of Guatemala in 1998 to that in 2013?
Give a very brief answer. 0.74. What is the ratio of the Employers (% of employed population) in Italy in 1998 to that in 2013?
Provide a short and direct response. 1.88. What is the ratio of the Employers (% of employed population) of Uruguay in 1998 to that in 2013?
Your response must be concise. 0.79. What is the ratio of the Employers (% of employed population) in Europe(all income levels) in 2000 to that in 2002?
Ensure brevity in your answer.  1.03. What is the ratio of the Employers (% of employed population) of Guatemala in 2000 to that in 2002?
Give a very brief answer. 0.67. What is the ratio of the Employers (% of employed population) of Italy in 2000 to that in 2002?
Ensure brevity in your answer.  1.12. What is the ratio of the Employers (% of employed population) of Uruguay in 2000 to that in 2002?
Your answer should be compact. 0.56. What is the ratio of the Employers (% of employed population) in Europe(all income levels) in 2000 to that in 2003?
Offer a terse response. 1.04. What is the ratio of the Employers (% of employed population) in Guatemala in 2000 to that in 2003?
Give a very brief answer. 0.59. What is the ratio of the Employers (% of employed population) of Italy in 2000 to that in 2003?
Provide a short and direct response. 1.11. What is the ratio of the Employers (% of employed population) in Uruguay in 2000 to that in 2003?
Make the answer very short. 1.16. What is the ratio of the Employers (% of employed population) in Europe(all income levels) in 2000 to that in 2010?
Your answer should be compact. 1.08. What is the ratio of the Employers (% of employed population) in Guatemala in 2000 to that in 2010?
Provide a short and direct response. 0.73. What is the ratio of the Employers (% of employed population) in Italy in 2000 to that in 2010?
Ensure brevity in your answer.  2.33. What is the ratio of the Employers (% of employed population) in Uruguay in 2000 to that in 2010?
Your response must be concise. 0.79. What is the ratio of the Employers (% of employed population) in Europe(all income levels) in 2000 to that in 2011?
Provide a succinct answer. 1.14. What is the ratio of the Employers (% of employed population) in Guatemala in 2000 to that in 2011?
Offer a very short reply. 1. What is the ratio of the Employers (% of employed population) in Italy in 2000 to that in 2011?
Keep it short and to the point. 2.27. What is the ratio of the Employers (% of employed population) in Uruguay in 2000 to that in 2011?
Offer a terse response. 0.67. What is the ratio of the Employers (% of employed population) of Europe(all income levels) in 2000 to that in 2012?
Provide a succinct answer. 1.13. What is the ratio of the Employers (% of employed population) in Guatemala in 2000 to that in 2012?
Keep it short and to the point. 0.62. What is the ratio of the Employers (% of employed population) of Italy in 2000 to that in 2012?
Make the answer very short. 2.21. What is the ratio of the Employers (% of employed population) in Uruguay in 2000 to that in 2012?
Offer a terse response. 0.76. What is the ratio of the Employers (% of employed population) of Europe(all income levels) in 2000 to that in 2013?
Offer a very short reply. 1.14. What is the ratio of the Employers (% of employed population) of Guatemala in 2000 to that in 2013?
Offer a terse response. 0.7. What is the ratio of the Employers (% of employed population) in Italy in 2000 to that in 2013?
Your answer should be compact. 2.05. What is the ratio of the Employers (% of employed population) of Uruguay in 2000 to that in 2013?
Your answer should be compact. 0.76. What is the ratio of the Employers (% of employed population) in Europe(all income levels) in 2002 to that in 2003?
Offer a very short reply. 1.01. What is the ratio of the Employers (% of employed population) of Guatemala in 2002 to that in 2003?
Provide a succinct answer. 0.89. What is the ratio of the Employers (% of employed population) in Italy in 2002 to that in 2003?
Provide a succinct answer. 0.99. What is the ratio of the Employers (% of employed population) in Uruguay in 2002 to that in 2003?
Your response must be concise. 2.05. What is the ratio of the Employers (% of employed population) of Europe(all income levels) in 2002 to that in 2010?
Offer a terse response. 1.05. What is the ratio of the Employers (% of employed population) of Guatemala in 2002 to that in 2010?
Make the answer very short. 1.09. What is the ratio of the Employers (% of employed population) of Italy in 2002 to that in 2010?
Provide a succinct answer. 2.08. What is the ratio of the Employers (% of employed population) of Uruguay in 2002 to that in 2010?
Ensure brevity in your answer.  1.39. What is the ratio of the Employers (% of employed population) in Europe(all income levels) in 2002 to that in 2011?
Your answer should be compact. 1.11. What is the ratio of the Employers (% of employed population) of Guatemala in 2002 to that in 2011?
Make the answer very short. 1.5. What is the ratio of the Employers (% of employed population) in Italy in 2002 to that in 2011?
Provide a succinct answer. 2.03. What is the ratio of the Employers (% of employed population) in Uruguay in 2002 to that in 2011?
Ensure brevity in your answer.  1.18. What is the ratio of the Employers (% of employed population) of Europe(all income levels) in 2002 to that in 2012?
Ensure brevity in your answer.  1.1. What is the ratio of the Employers (% of employed population) in Guatemala in 2002 to that in 2012?
Ensure brevity in your answer.  0.92. What is the ratio of the Employers (% of employed population) of Italy in 2002 to that in 2012?
Your answer should be very brief. 1.97. What is the ratio of the Employers (% of employed population) in Uruguay in 2002 to that in 2012?
Ensure brevity in your answer.  1.34. What is the ratio of the Employers (% of employed population) in Europe(all income levels) in 2002 to that in 2013?
Ensure brevity in your answer.  1.11. What is the ratio of the Employers (% of employed population) of Guatemala in 2002 to that in 2013?
Provide a short and direct response. 1.04. What is the ratio of the Employers (% of employed population) of Italy in 2002 to that in 2013?
Offer a terse response. 1.83. What is the ratio of the Employers (% of employed population) in Uruguay in 2002 to that in 2013?
Provide a short and direct response. 1.34. What is the ratio of the Employers (% of employed population) of Europe(all income levels) in 2003 to that in 2010?
Provide a succinct answer. 1.04. What is the ratio of the Employers (% of employed population) of Guatemala in 2003 to that in 2010?
Keep it short and to the point. 1.23. What is the ratio of the Employers (% of employed population) of Italy in 2003 to that in 2010?
Offer a terse response. 2.11. What is the ratio of the Employers (% of employed population) of Uruguay in 2003 to that in 2010?
Make the answer very short. 0.68. What is the ratio of the Employers (% of employed population) in Europe(all income levels) in 2003 to that in 2011?
Your answer should be very brief. 1.1. What is the ratio of the Employers (% of employed population) of Guatemala in 2003 to that in 2011?
Make the answer very short. 1.69. What is the ratio of the Employers (% of employed population) in Italy in 2003 to that in 2011?
Give a very brief answer. 2.05. What is the ratio of the Employers (% of employed population) of Uruguay in 2003 to that in 2011?
Make the answer very short. 0.58. What is the ratio of the Employers (% of employed population) in Europe(all income levels) in 2003 to that in 2012?
Give a very brief answer. 1.09. What is the ratio of the Employers (% of employed population) of Guatemala in 2003 to that in 2012?
Your answer should be very brief. 1.04. What is the ratio of the Employers (% of employed population) in Italy in 2003 to that in 2012?
Offer a terse response. 2. What is the ratio of the Employers (% of employed population) of Uruguay in 2003 to that in 2012?
Provide a succinct answer. 0.66. What is the ratio of the Employers (% of employed population) of Europe(all income levels) in 2003 to that in 2013?
Your response must be concise. 1.09. What is the ratio of the Employers (% of employed population) of Guatemala in 2003 to that in 2013?
Make the answer very short. 1.17. What is the ratio of the Employers (% of employed population) of Italy in 2003 to that in 2013?
Provide a short and direct response. 1.85. What is the ratio of the Employers (% of employed population) in Uruguay in 2003 to that in 2013?
Make the answer very short. 0.66. What is the ratio of the Employers (% of employed population) of Europe(all income levels) in 2010 to that in 2011?
Make the answer very short. 1.06. What is the ratio of the Employers (% of employed population) in Guatemala in 2010 to that in 2011?
Provide a succinct answer. 1.38. What is the ratio of the Employers (% of employed population) in Uruguay in 2010 to that in 2011?
Ensure brevity in your answer.  0.85. What is the ratio of the Employers (% of employed population) in Europe(all income levels) in 2010 to that in 2012?
Your answer should be compact. 1.05. What is the ratio of the Employers (% of employed population) in Guatemala in 2010 to that in 2012?
Offer a terse response. 0.85. What is the ratio of the Employers (% of employed population) of Uruguay in 2010 to that in 2012?
Offer a terse response. 0.97. What is the ratio of the Employers (% of employed population) of Europe(all income levels) in 2010 to that in 2013?
Provide a short and direct response. 1.05. What is the ratio of the Employers (% of employed population) in Guatemala in 2010 to that in 2013?
Make the answer very short. 0.96. What is the ratio of the Employers (% of employed population) of Italy in 2010 to that in 2013?
Offer a very short reply. 0.88. What is the ratio of the Employers (% of employed population) in Uruguay in 2010 to that in 2013?
Offer a terse response. 0.97. What is the ratio of the Employers (% of employed population) in Europe(all income levels) in 2011 to that in 2012?
Ensure brevity in your answer.  0.99. What is the ratio of the Employers (% of employed population) of Guatemala in 2011 to that in 2012?
Ensure brevity in your answer.  0.62. What is the ratio of the Employers (% of employed population) of Italy in 2011 to that in 2012?
Provide a succinct answer. 0.97. What is the ratio of the Employers (% of employed population) of Uruguay in 2011 to that in 2012?
Ensure brevity in your answer.  1.14. What is the ratio of the Employers (% of employed population) of Europe(all income levels) in 2011 to that in 2013?
Your answer should be very brief. 1. What is the ratio of the Employers (% of employed population) in Guatemala in 2011 to that in 2013?
Make the answer very short. 0.7. What is the ratio of the Employers (% of employed population) in Italy in 2011 to that in 2013?
Make the answer very short. 0.9. What is the ratio of the Employers (% of employed population) of Uruguay in 2011 to that in 2013?
Your answer should be very brief. 1.14. What is the ratio of the Employers (% of employed population) in Europe(all income levels) in 2012 to that in 2013?
Your answer should be very brief. 1. What is the ratio of the Employers (% of employed population) in Guatemala in 2012 to that in 2013?
Provide a short and direct response. 1.13. What is the ratio of the Employers (% of employed population) in Italy in 2012 to that in 2013?
Your answer should be very brief. 0.93. What is the ratio of the Employers (% of employed population) in Uruguay in 2012 to that in 2013?
Your answer should be very brief. 1. What is the difference between the highest and the second highest Employers (% of employed population) in Europe(all income levels)?
Make the answer very short. 0.05. What is the difference between the highest and the second highest Employers (% of employed population) of Uruguay?
Keep it short and to the point. 0.6. What is the difference between the highest and the lowest Employers (% of employed population) of Europe(all income levels)?
Offer a very short reply. 0.32. What is the difference between the highest and the lowest Employers (% of employed population) of Italy?
Make the answer very short. 4.8. 